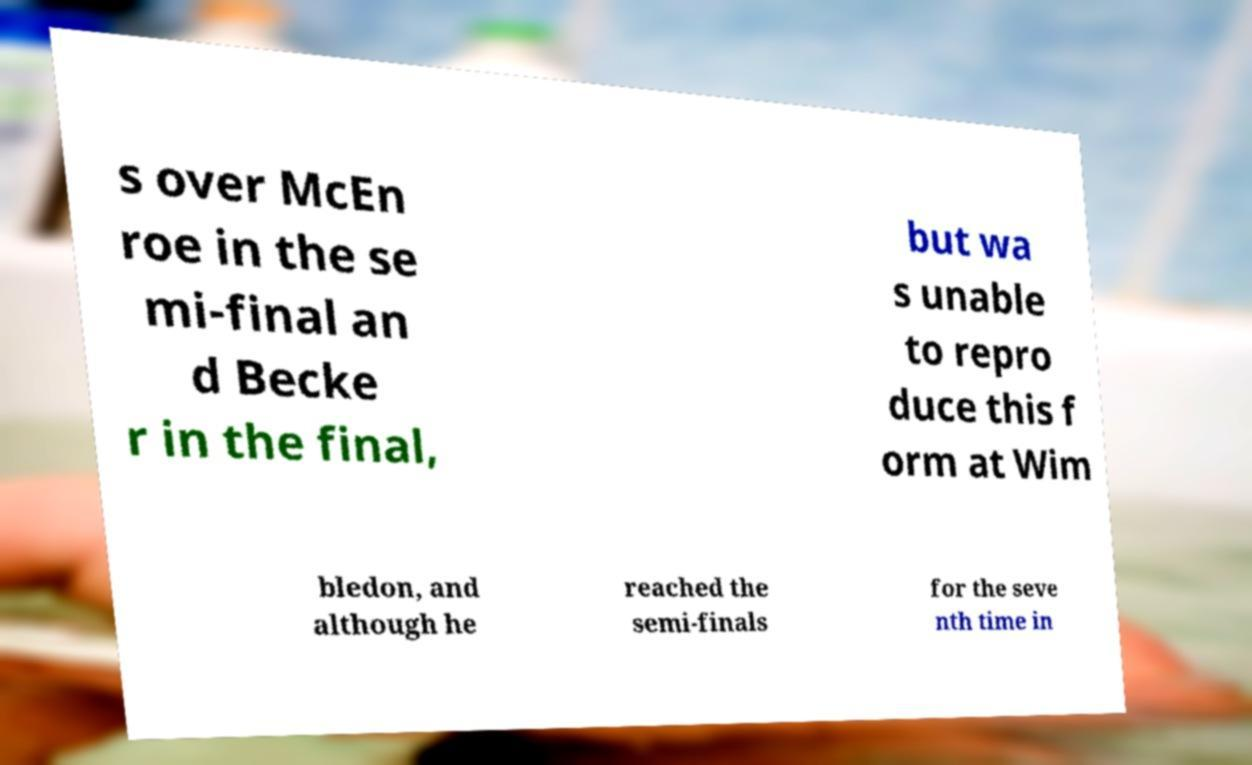Please identify and transcribe the text found in this image. s over McEn roe in the se mi-final an d Becke r in the final, but wa s unable to repro duce this f orm at Wim bledon, and although he reached the semi-finals for the seve nth time in 